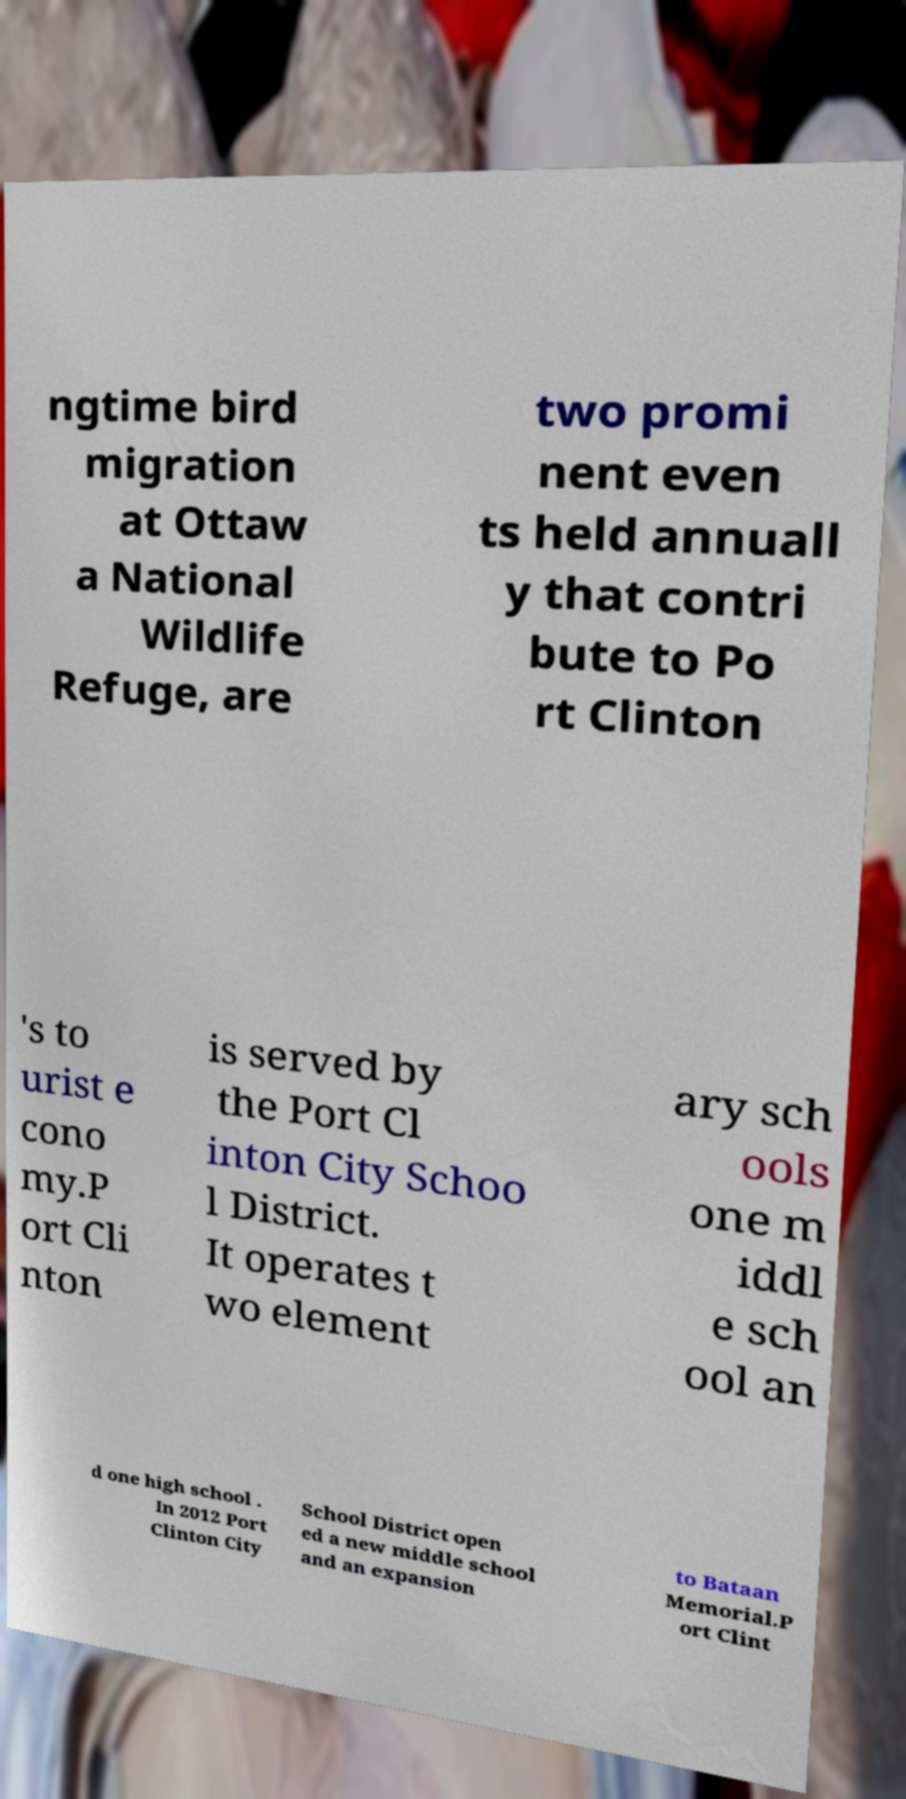What messages or text are displayed in this image? I need them in a readable, typed format. ngtime bird migration at Ottaw a National Wildlife Refuge, are two promi nent even ts held annuall y that contri bute to Po rt Clinton 's to urist e cono my.P ort Cli nton is served by the Port Cl inton City Schoo l District. It operates t wo element ary sch ools one m iddl e sch ool an d one high school . In 2012 Port Clinton City School District open ed a new middle school and an expansion to Bataan Memorial.P ort Clint 